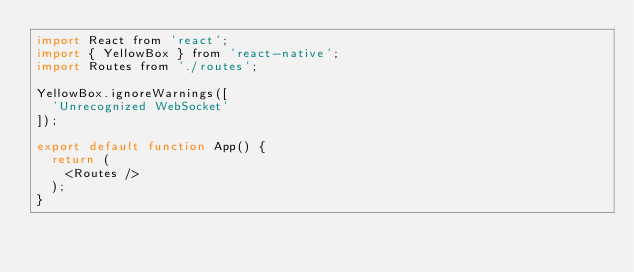<code> <loc_0><loc_0><loc_500><loc_500><_JavaScript_>import React from 'react';
import { YellowBox } from 'react-native';
import Routes from './routes';

YellowBox.ignoreWarnings([
  'Unrecognized WebSocket'
]);

export default function App() {
  return (
    <Routes />
  );
}</code> 